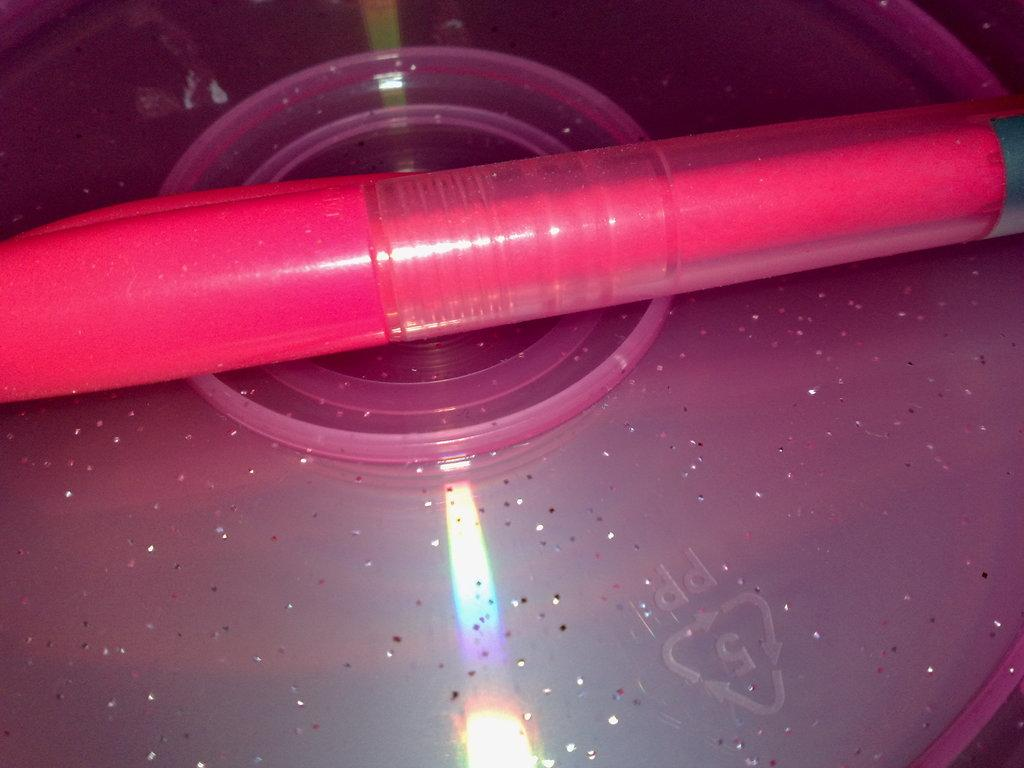What type of objects are made of plastic in the image? There are two plastic things in the image. Can you describe the color of one of the plastic objects? One of the plastic things is pink in color. What can be seen on the bottom side of the image? There is a reflection of lights on the bottom side of the image. What type of fuel is being used by the appliance in the image? There is no appliance present in the image, so it is not possible to determine what type of fuel it might use. 